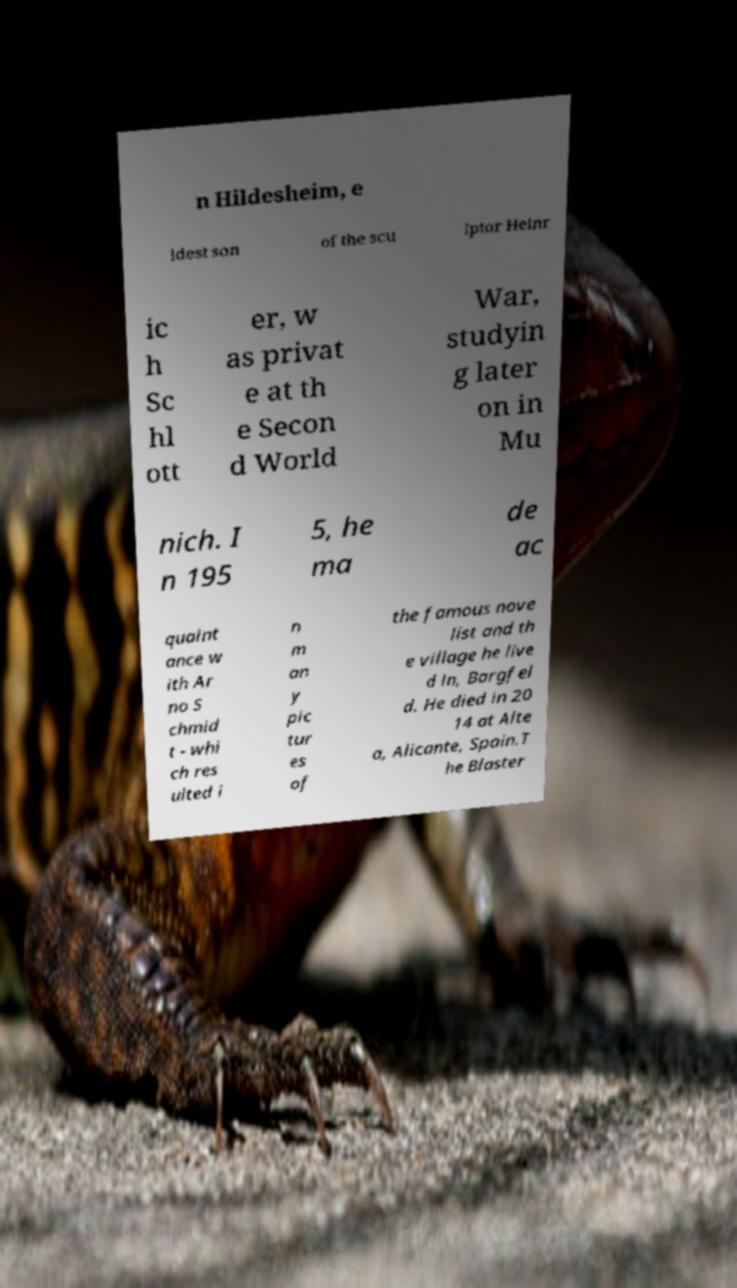I need the written content from this picture converted into text. Can you do that? n Hildesheim, e ldest son of the scu lptor Heinr ic h Sc hl ott er, w as privat e at th e Secon d World War, studyin g later on in Mu nich. I n 195 5, he ma de ac quaint ance w ith Ar no S chmid t - whi ch res ulted i n m an y pic tur es of the famous nove list and th e village he live d in, Bargfel d. He died in 20 14 at Alte a, Alicante, Spain.T he Blaster 